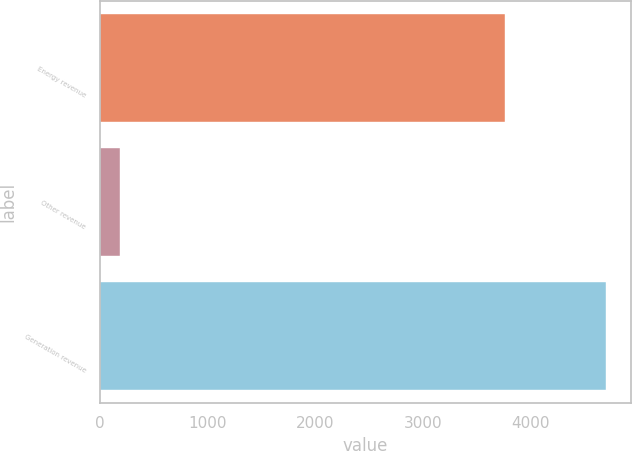Convert chart. <chart><loc_0><loc_0><loc_500><loc_500><bar_chart><fcel>Energy revenue<fcel>Other revenue<fcel>Generation revenue<nl><fcel>3761<fcel>192<fcel>4703<nl></chart> 